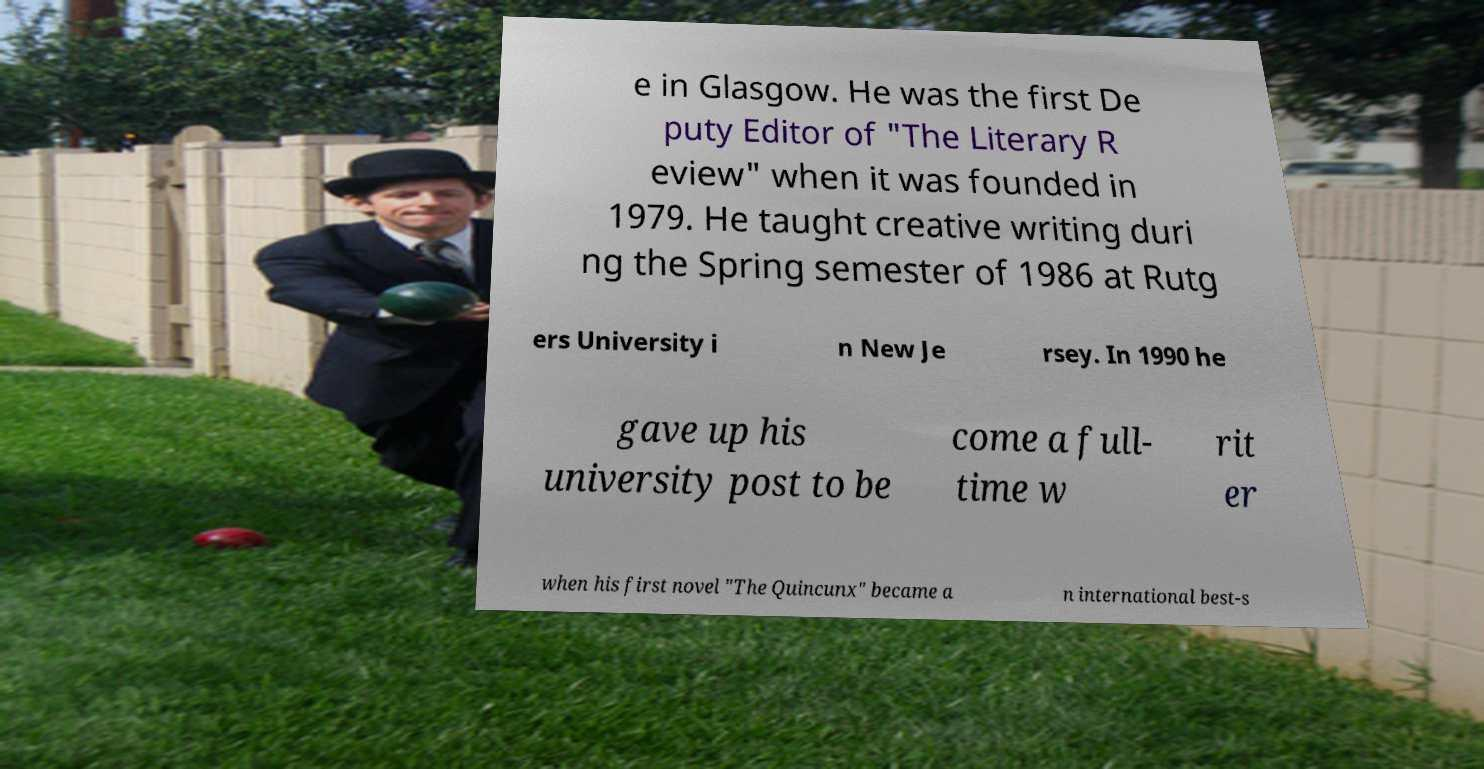Could you extract and type out the text from this image? e in Glasgow. He was the first De puty Editor of "The Literary R eview" when it was founded in 1979. He taught creative writing duri ng the Spring semester of 1986 at Rutg ers University i n New Je rsey. In 1990 he gave up his university post to be come a full- time w rit er when his first novel "The Quincunx" became a n international best-s 